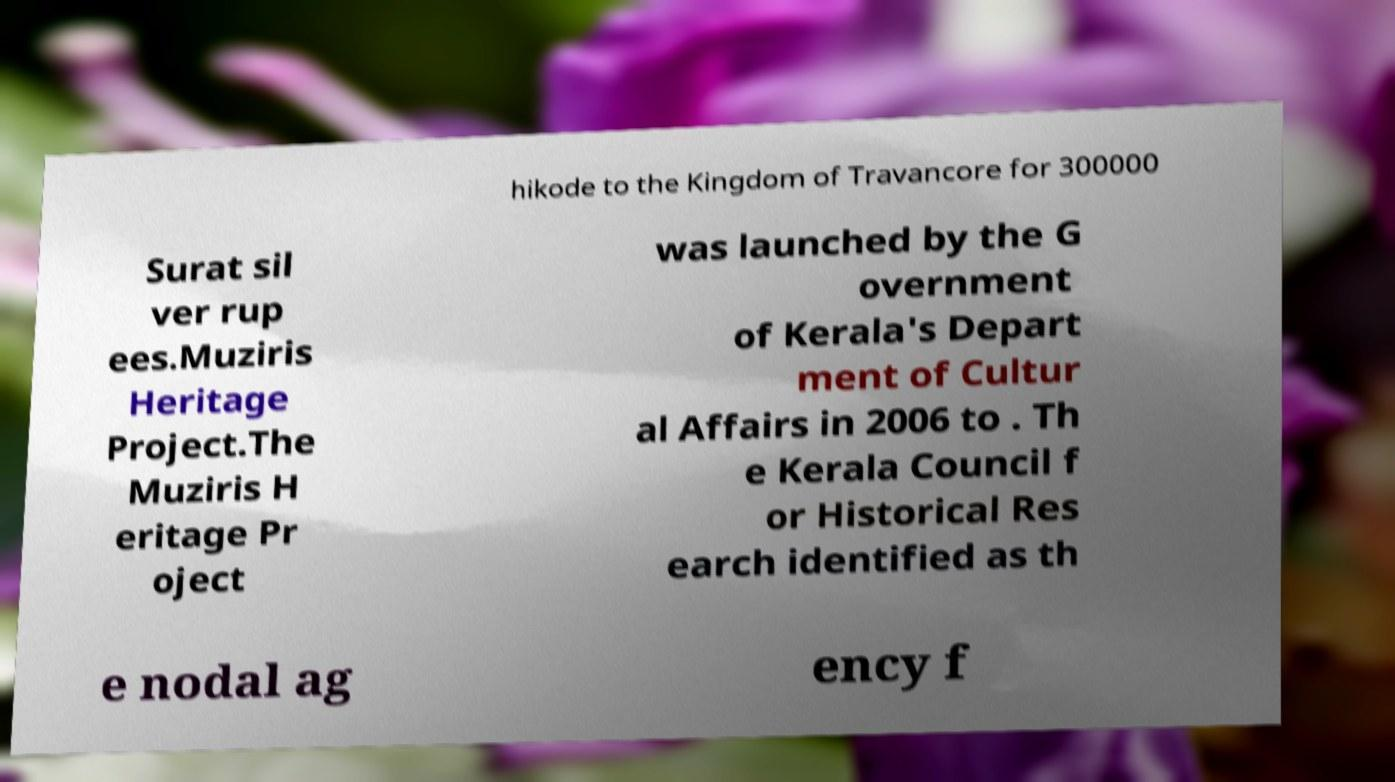Can you accurately transcribe the text from the provided image for me? hikode to the Kingdom of Travancore for 300000 Surat sil ver rup ees.Muziris Heritage Project.The Muziris H eritage Pr oject was launched by the G overnment of Kerala's Depart ment of Cultur al Affairs in 2006 to . Th e Kerala Council f or Historical Res earch identified as th e nodal ag ency f 